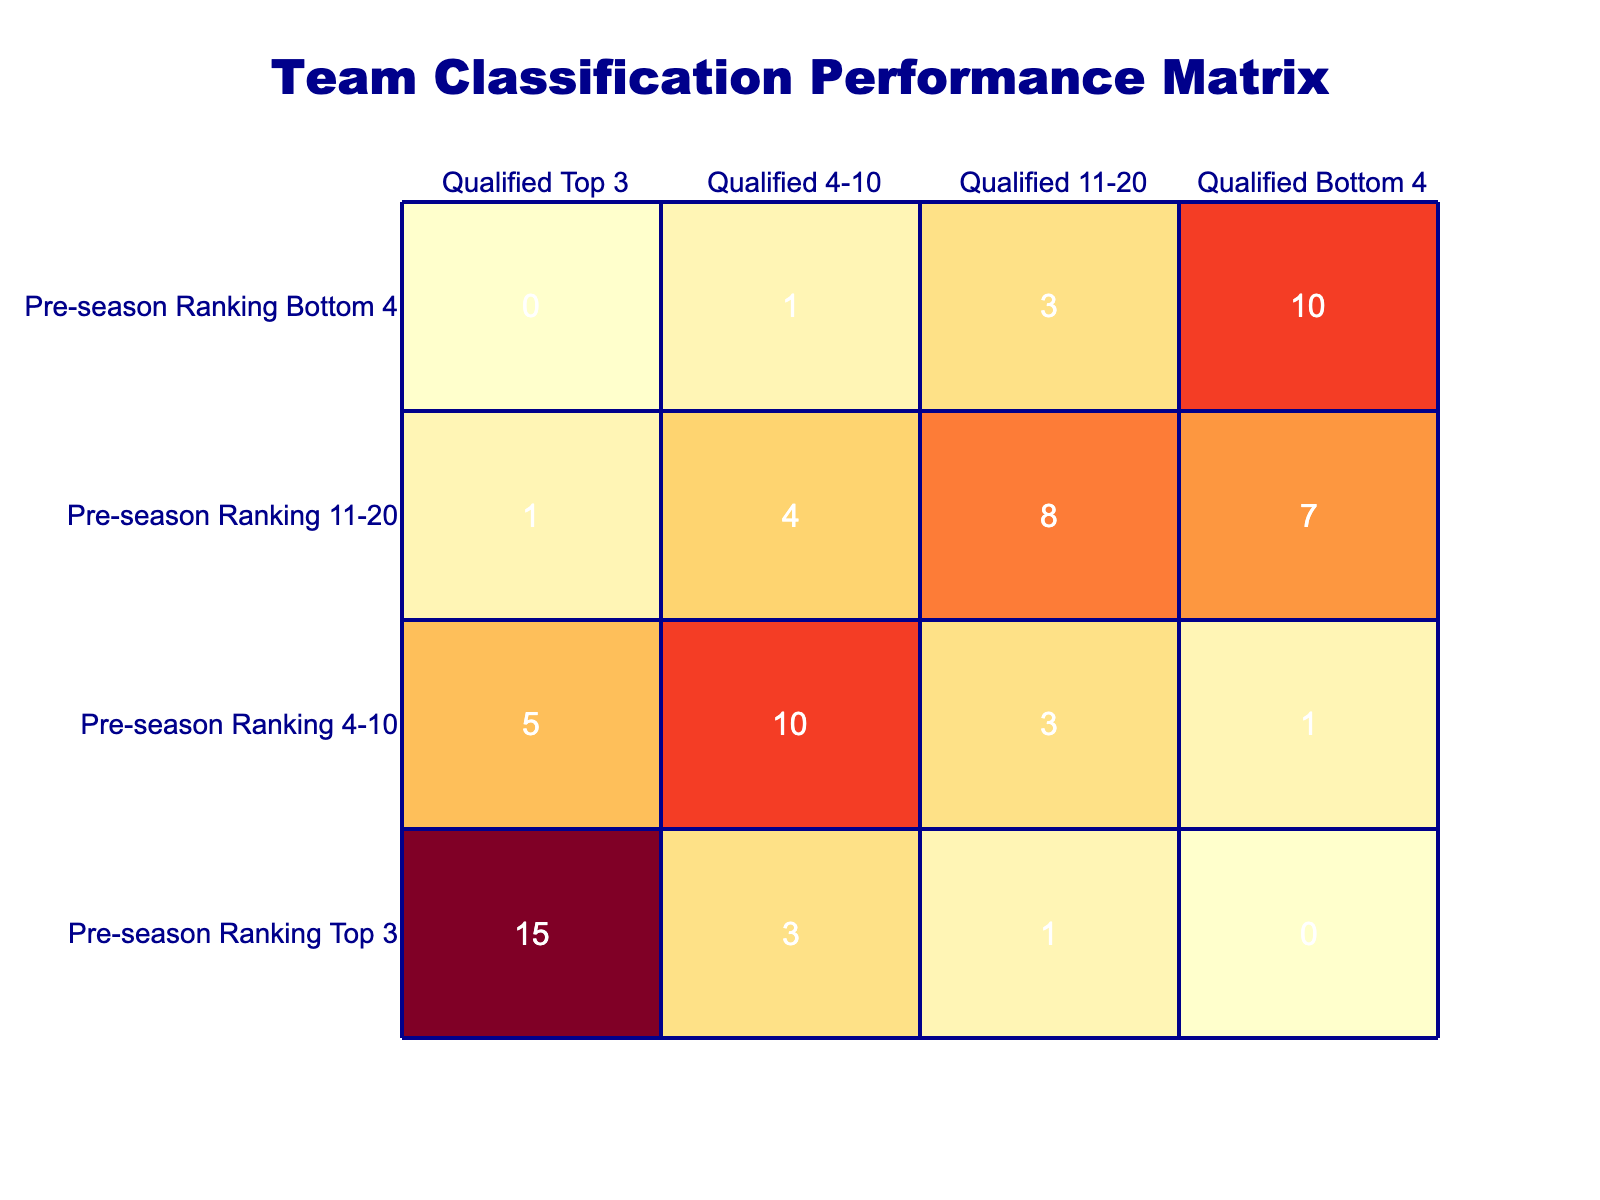What is the total number of teams that qualified in the Top 3 with a pre-season ranking of Top 3? Looking at the table, under the "Qualified Top 3" column, the value corresponding to "Pre-season Ranking Top 3" is 15. Therefore, the total number of teams that qualified in the Top 3 is 15.
Answer: 15 How many teams with a pre-season ranking of 11-20 were in the Qualified Bottom 4? The table shows that for the "Qualified Bottom 4" column, under "Pre-season Ranking 11-20," the value is 7. Thus, there are 7 teams in that category.
Answer: 7 Is there any team with a pre-season ranking of Bottom 4 that qualified in the Top 3? According to the table, under the "Qualified Top 3" column for "Pre-season Ranking Bottom 4," the value is 0. This indicates that no team in this ranking qualified in the Top 3.
Answer: No What is the total number of teams that qualified between 4-10, from all pre-season rankings? We need to sum the values in the "Qualified 4-10" column across all pre-season rankings: 3 (Top 3) + 10 (4-10) + 4 (11-20) + 1 (Bottom 4) = 18. Thus, the total is 18 teams.
Answer: 18 What is the difference in the number of teams that qualified in the 11-20 category versus the Top 3 category, for those with a pre-season ranking of 4-10? From the table, for "Pre-season Ranking 4-10," the number of teams that qualified in "Qualified 11-20" is 3, while those in "Qualified Top 3" is 5. The difference is calculated as 5 - 3 = 2.
Answer: 2 How many teams from the pre-season ranking Top 3 also qualified in the 11-20 range? The table indicates that under "Qualified 11-20," for "Pre-season Ranking Top 3," the value is 1. Therefore, only 1 team from that ranking also qualified in the 11-20 range.
Answer: 1 What percentage of teams ranked 11-20 ended up in the Top 3? For "Pre-season Ranking 11-20," a total of 20 teams are considered (1+4+8+7). Out of these, only 1 qualified in the Top 3. To find the percentage, we use (1/20)*100 = 5%.
Answer: 5% What is the highest number of teams that qualified in any single pre-season ranking category? Examining the table closely, the highest value appears in the "Qualified Top 3" for "Pre-season Ranking Top 3," which is 15. No other category exceeds this number.
Answer: 15 